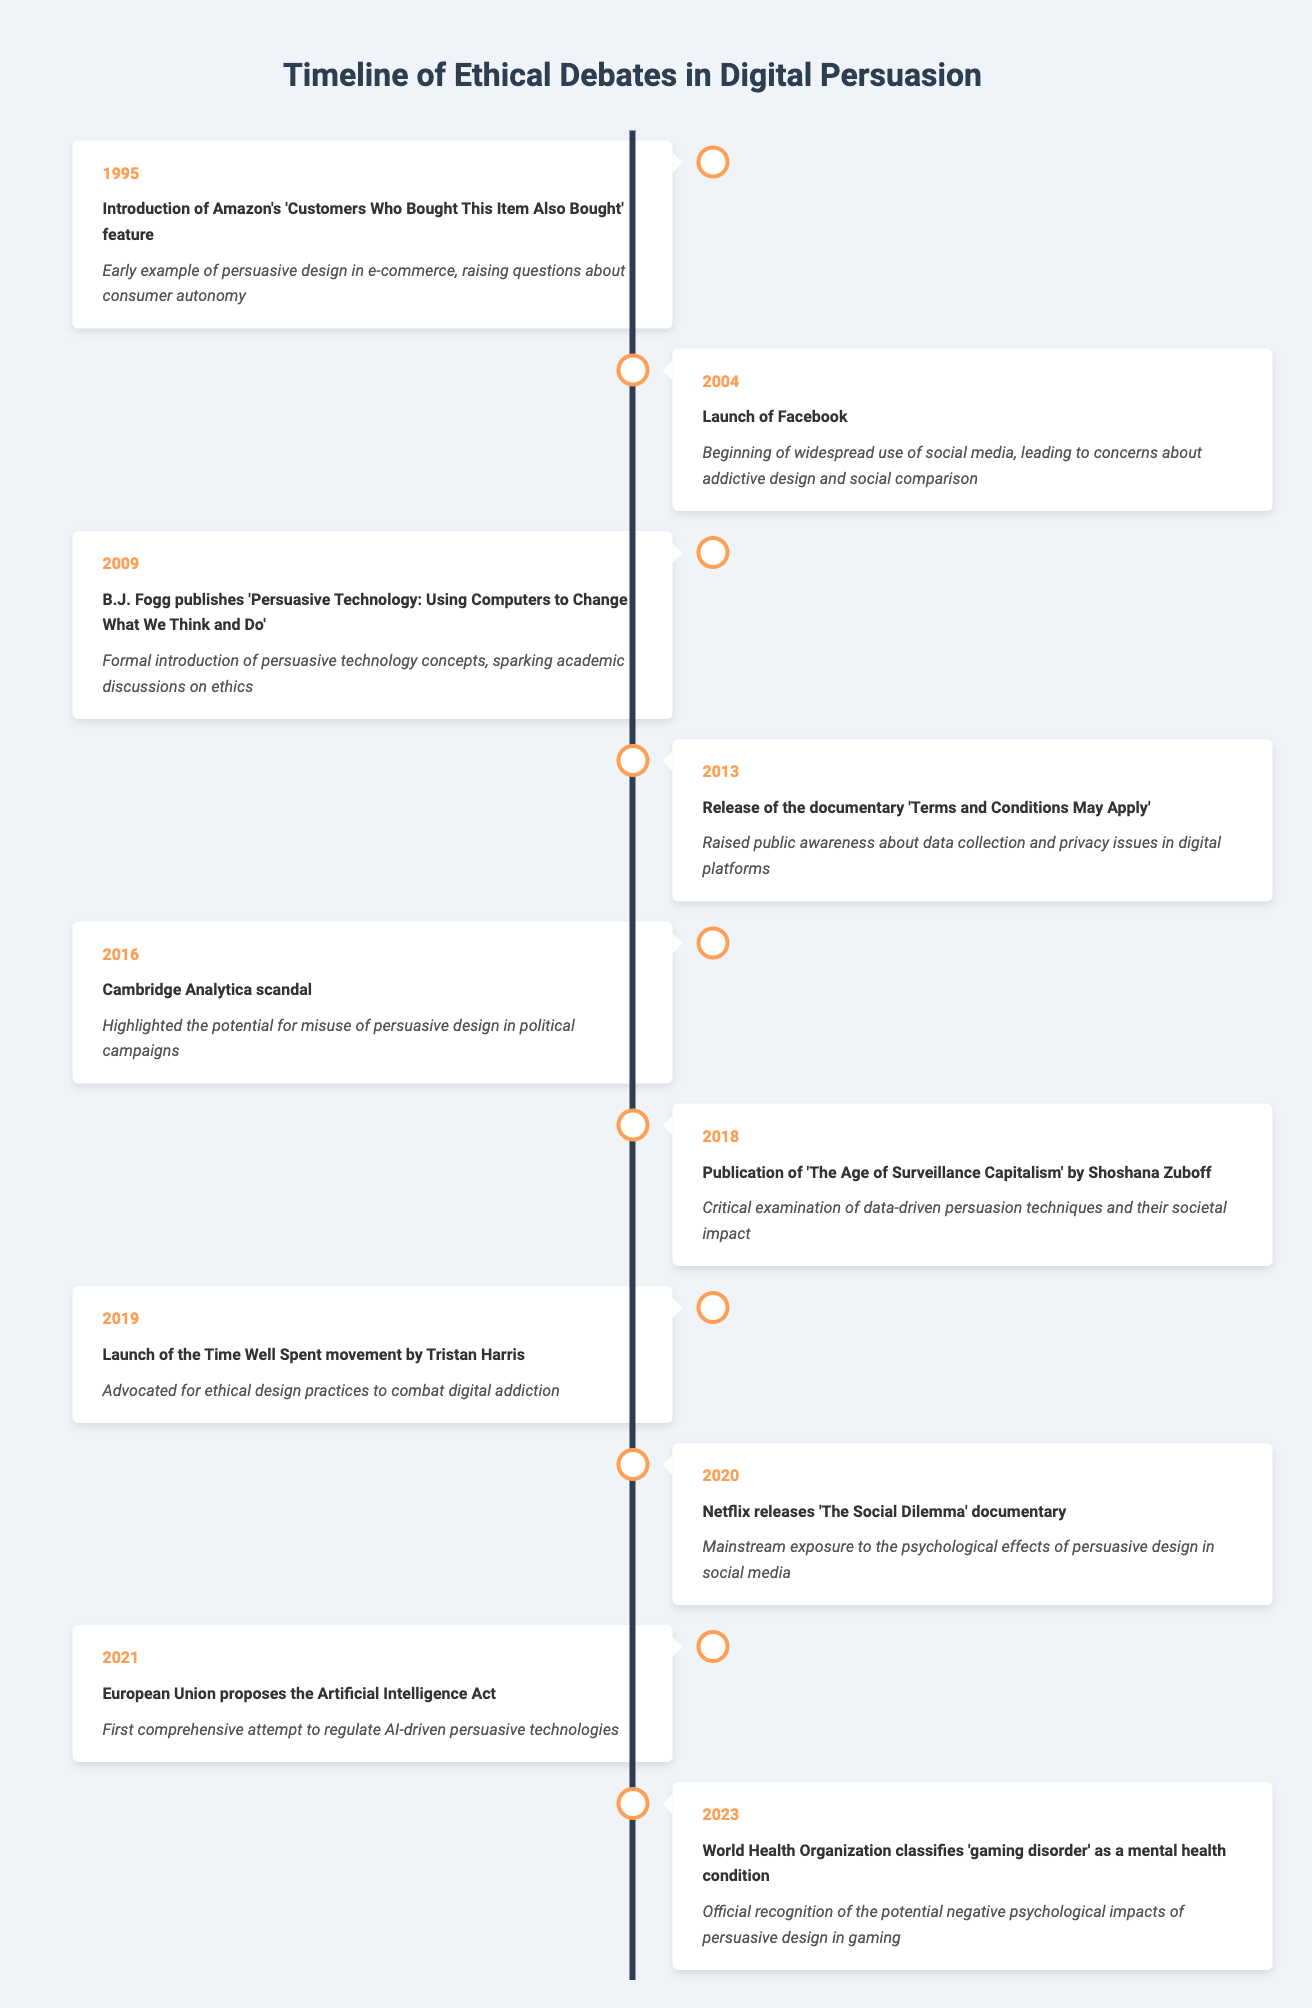What year did the Cambridge Analytica scandal occur? The table lists the event "Cambridge Analytica scandal" under the year 2016. Therefore, the year it occurred is directly provided.
Answer: 2016 What event in 2004 raised concerns about addictive design? The event listed for 2004 is the "Launch of Facebook," which mentions it led to concerns about addictive design, making it the correct answer.
Answer: Launch of Facebook How many events occurred between 2010 and 2020? From the table, the events listed between 2010 and 2020 are the Cambridge Analytica scandal (2016), Zuboff's book (2018), Time Well Spent movement (2019), and The Social Dilemma documentary (2020). Counting these gives us a total of four events.
Answer: 4 True or False: The year 2013 marked the release of a documentary that raised public awareness about data privacy. The table states that in 2013, the documentary "Terms and Conditions May Apply" was released, which aligns with raising awareness about data privacy. Thus, the statement is true.
Answer: True Which event signified the first attempt to regulate AI-driven persuasive technologies, and in what year did it happen? The "European Union proposes the Artificial Intelligence Act" in the year 2021 is stated in the table as the first comprehensive attempt to regulate such technologies. Therefore, both the event and the year can be identified directly from the table.
Answer: European Union proposes the Artificial Intelligence Act in 2021 What is the significance of the event in 2018 related to persuasive design? According to the table, the publication of "The Age of Surveillance Capitalism" by Shoshana Zuboff in 2018 critically examined the impact of data-driven persuasion techniques on society. It illustrates the concerns of persuasive design's effects.
Answer: Critical examination of data-driven persuasion techniques and their societal impact How many years passed between the introduction of Amazon's feature in 1995 and the launch of Facebook in 2004? The gap between 1995 and 2004 is 9 years (2004 - 1995 = 9). This requires simple subtraction to calculate the difference.
Answer: 9 years Which event in 2019 advocated for ethical design practices? The table lists "Launch of the Time Well Spent movement by Tristan Harris" for the year 2019 as an advocacy for ethical design practices. This can be confirmed by reading the significance related to that event.
Answer: Launch of the Time Well Spent movement by Tristan Harris 